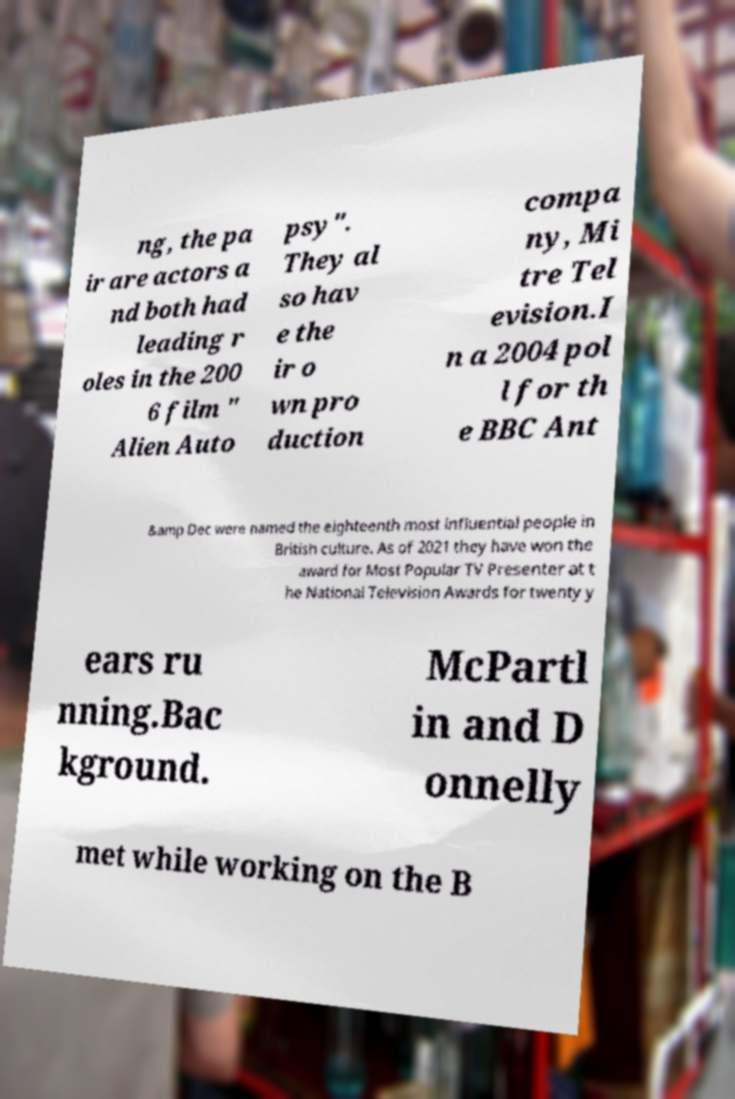Please read and relay the text visible in this image. What does it say? ng, the pa ir are actors a nd both had leading r oles in the 200 6 film " Alien Auto psy". They al so hav e the ir o wn pro duction compa ny, Mi tre Tel evision.I n a 2004 pol l for th e BBC Ant &amp Dec were named the eighteenth most influential people in British culture. As of 2021 they have won the award for Most Popular TV Presenter at t he National Television Awards for twenty y ears ru nning.Bac kground. McPartl in and D onnelly met while working on the B 